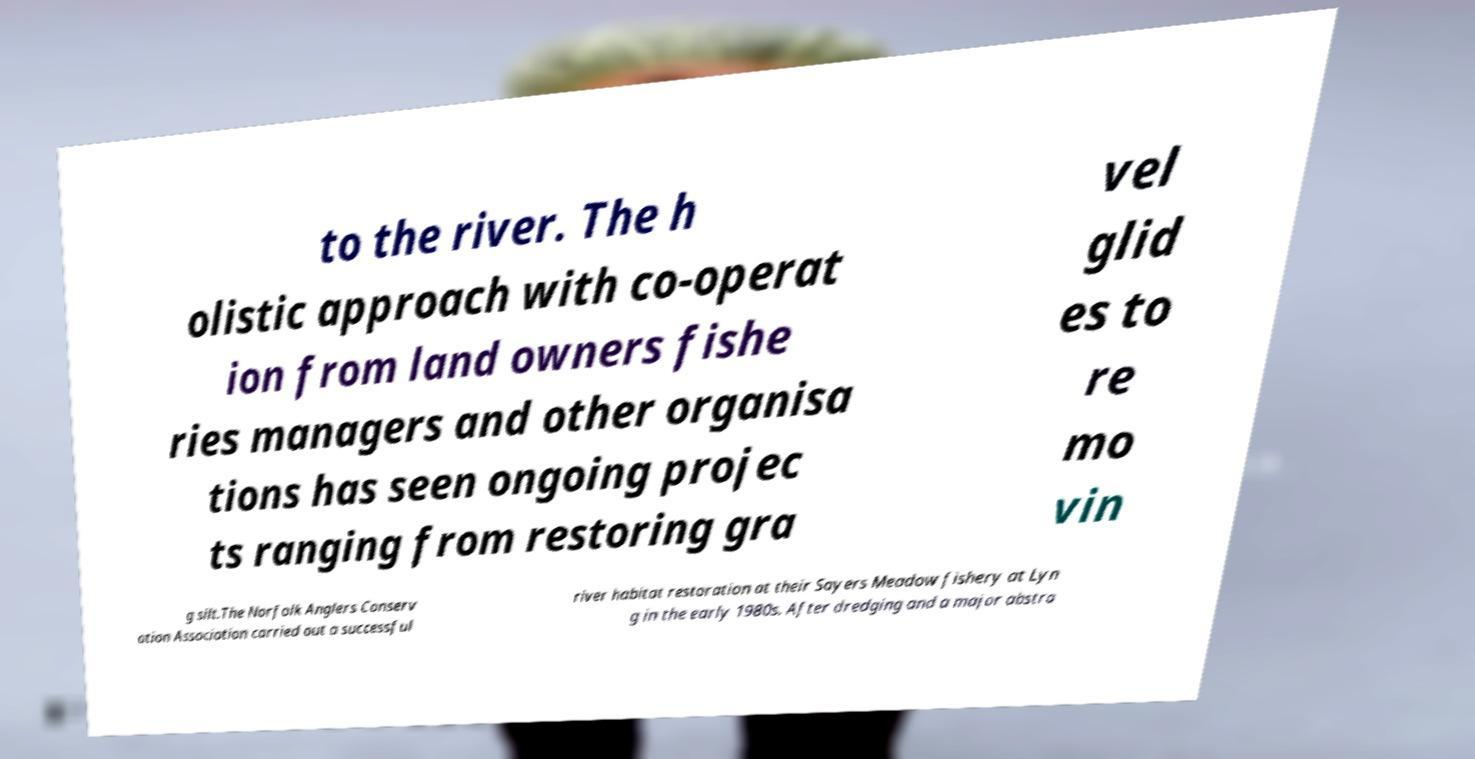For documentation purposes, I need the text within this image transcribed. Could you provide that? to the river. The h olistic approach with co-operat ion from land owners fishe ries managers and other organisa tions has seen ongoing projec ts ranging from restoring gra vel glid es to re mo vin g silt.The Norfolk Anglers Conserv ation Association carried out a successful river habitat restoration at their Sayers Meadow fishery at Lyn g in the early 1980s. After dredging and a major abstra 